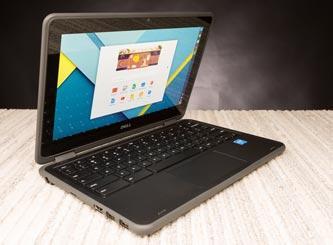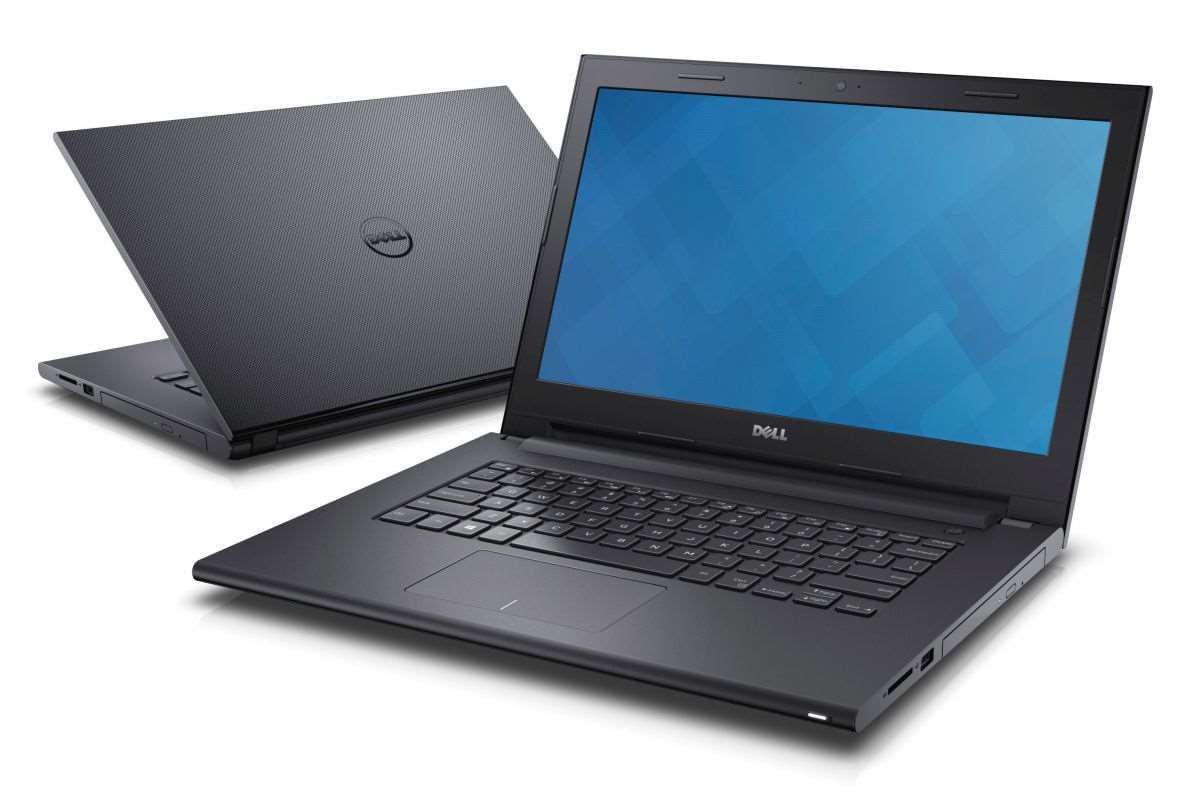The first image is the image on the left, the second image is the image on the right. Given the left and right images, does the statement "there are two laptops in the image, one is open and facing toward the camera, and one facing away" hold true? Answer yes or no. Yes. The first image is the image on the left, the second image is the image on the right. For the images shown, is this caption "One image shows exactly two laptops with one laptop having a blue background on the screen and the other screen not visible, while the other image shows only one laptop with a colorful image on the screen." true? Answer yes or no. Yes. 